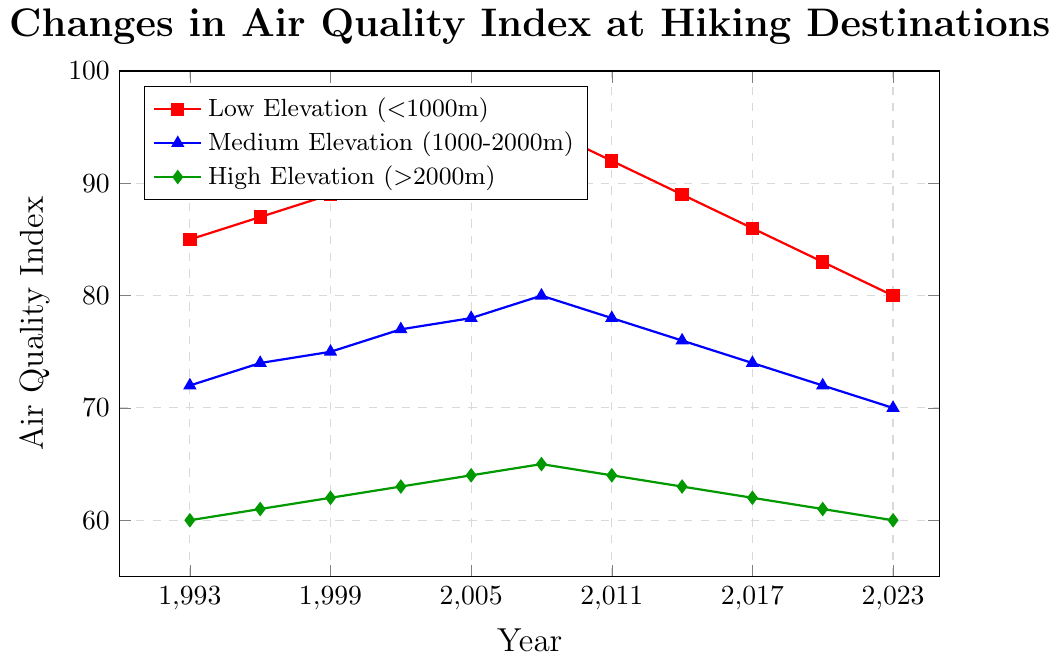What's the trend in air quality at low elevation hiking destinations over the past 30 years? To determine the trend in air quality at low elevation destinations (<1000m) from 1993 to 2023, observe the values at different years and notice that the air quality index rises until 2008, peaking at 95, and then starts to decline steadily after that, reaching 80 by 2023.
Answer: Declining after initial rise Between which years did the air quality index at medium elevation show a consistent decrease? Observe the medium elevation line (blue) and identify the period where the values consistently lowered. From 2008 (80) until 2023 (70), the values decrease consistently.
Answer: 2008 to 2023 Which elevation category has the best air quality in 2005? Compare the air quality index values for low, medium, and high elevations in 2005. The values are 93 for low, 78 for medium, and 64 for high elevations respectively. Since a lower index indicates better air quality, high elevation (>2000m) has the best air quality in 2005.
Answer: High elevation On average, by how much did the air quality index at high elevations change every decade? Calculate the change between each decade: 
1993-2003 (60 to 63, change = 3), 
2003-2013 (63 to 63, change = 0), 
2013-2023 (63 to 60, change = -3). 
Average change = (3 + 0 + (-3)) / 3 = 0.
Answer: 0 Which elevation category shows the steepest decline from its peak value in 2008 to its value in 2023? Compare the peak values in 2008 to the 2023 values for all elevations:
Low elevation: 95 (peak) - 80 (2023) = 15
Medium elevation: 80 (peak) - 70 (2023) = 10
High elevation: 65 (peak) - 60 (2023) = 5
The low elevation shows the steepest decline of 15 units.
Answer: Low elevation Does the air quality index at high elevations ever decrease back to its starting value in 1993? Check if the index for high elevations (>2000m), starting at 60 in 1993, ever returns to this value evidently by 2023. In 2023, the index is 60, which matches the starting value.
Answer: Yes What is the air quality index difference between low and high elevations in 2002? Look at the values for low and high elevations in 2002:
Low elevation: 91, High elevation: 63. The difference is 91 - 63 = 28.
Answer: 28 Which year saw high elevation air quality index at its maximum? Track the high elevation air quality index year-wise from 1993 to 2023 and find the maximum value. The highest value in the data is 65, occurring in 2008.
Answer: 2008 How did the air quality index at medium elevations change from 1999 to 2020? Check the values for medium elevations in 1999 and 2020: 
1999: 75, 
2020: 72. 
The index decreased by 75 - 72 = 3 units.
Answer: Decreased by 3 units 